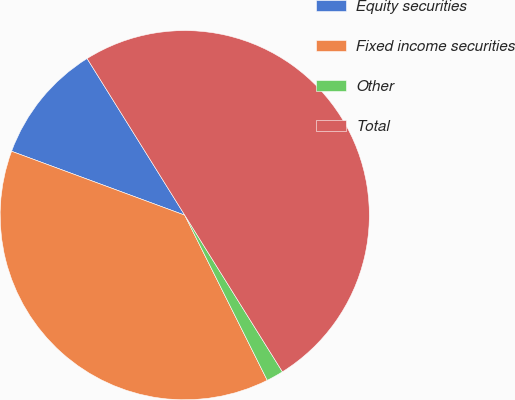<chart> <loc_0><loc_0><loc_500><loc_500><pie_chart><fcel>Equity securities<fcel>Fixed income securities<fcel>Other<fcel>Total<nl><fcel>10.5%<fcel>38.0%<fcel>1.5%<fcel>50.0%<nl></chart> 